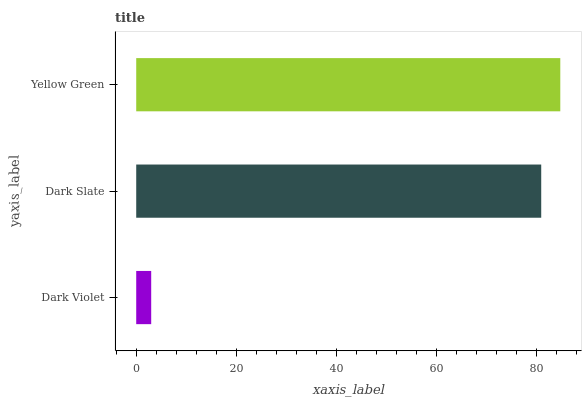Is Dark Violet the minimum?
Answer yes or no. Yes. Is Yellow Green the maximum?
Answer yes or no. Yes. Is Dark Slate the minimum?
Answer yes or no. No. Is Dark Slate the maximum?
Answer yes or no. No. Is Dark Slate greater than Dark Violet?
Answer yes or no. Yes. Is Dark Violet less than Dark Slate?
Answer yes or no. Yes. Is Dark Violet greater than Dark Slate?
Answer yes or no. No. Is Dark Slate less than Dark Violet?
Answer yes or no. No. Is Dark Slate the high median?
Answer yes or no. Yes. Is Dark Slate the low median?
Answer yes or no. Yes. Is Yellow Green the high median?
Answer yes or no. No. Is Yellow Green the low median?
Answer yes or no. No. 